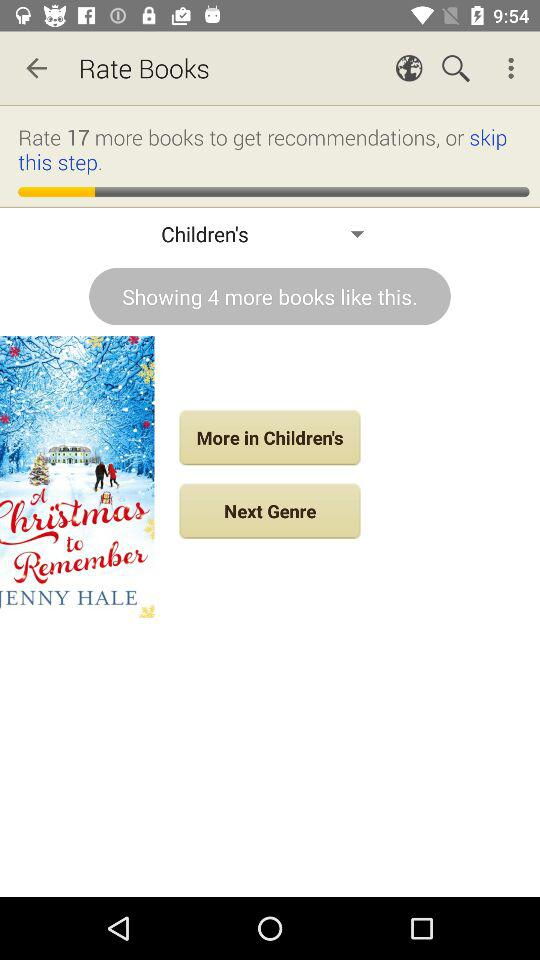How many more books do I need to rate to get recommendations?
Answer the question using a single word or phrase. 17 